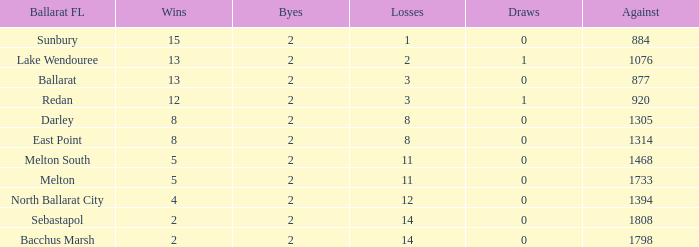How many Losses have a Ballarat FL of melton south, and an Against larger than 1468? 0.0. Help me parse the entirety of this table. {'header': ['Ballarat FL', 'Wins', 'Byes', 'Losses', 'Draws', 'Against'], 'rows': [['Sunbury', '15', '2', '1', '0', '884'], ['Lake Wendouree', '13', '2', '2', '1', '1076'], ['Ballarat', '13', '2', '3', '0', '877'], ['Redan', '12', '2', '3', '1', '920'], ['Darley', '8', '2', '8', '0', '1305'], ['East Point', '8', '2', '8', '0', '1314'], ['Melton South', '5', '2', '11', '0', '1468'], ['Melton', '5', '2', '11', '0', '1733'], ['North Ballarat City', '4', '2', '12', '0', '1394'], ['Sebastapol', '2', '2', '14', '0', '1808'], ['Bacchus Marsh', '2', '2', '14', '0', '1798']]} 